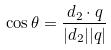Convert formula to latex. <formula><loc_0><loc_0><loc_500><loc_500>\cos \theta = \frac { d _ { 2 } \cdot q } { | d _ { 2 } | | q | }</formula> 